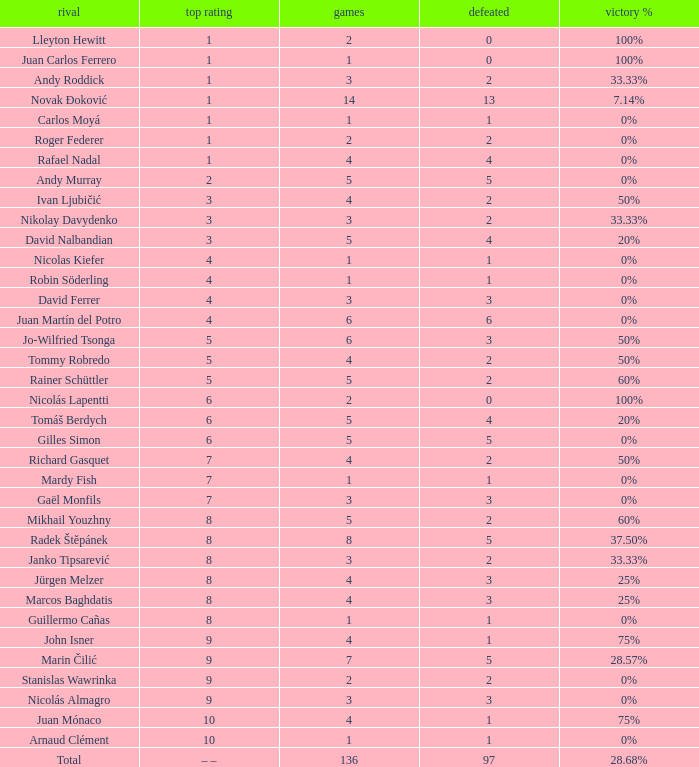What is the total number of Lost for the Highest Ranking of – –? 1.0. 